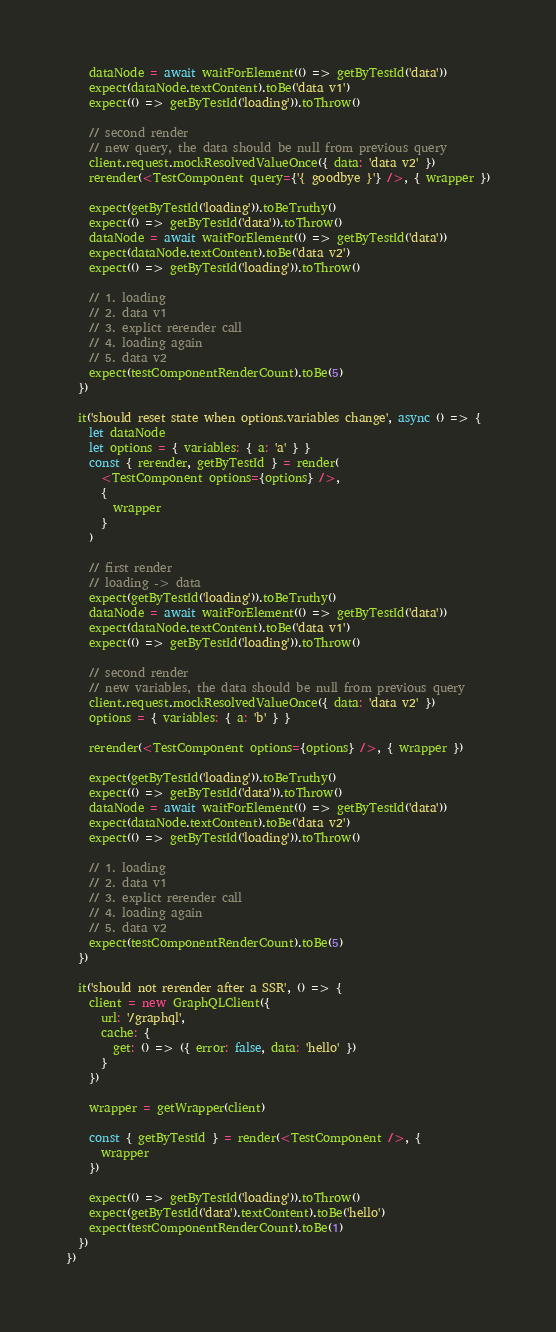Convert code to text. <code><loc_0><loc_0><loc_500><loc_500><_JavaScript_>    dataNode = await waitForElement(() => getByTestId('data'))
    expect(dataNode.textContent).toBe('data v1')
    expect(() => getByTestId('loading')).toThrow()

    // second render
    // new query, the data should be null from previous query
    client.request.mockResolvedValueOnce({ data: 'data v2' })
    rerender(<TestComponent query={'{ goodbye }'} />, { wrapper })

    expect(getByTestId('loading')).toBeTruthy()
    expect(() => getByTestId('data')).toThrow()
    dataNode = await waitForElement(() => getByTestId('data'))
    expect(dataNode.textContent).toBe('data v2')
    expect(() => getByTestId('loading')).toThrow()

    // 1. loading
    // 2. data v1
    // 3. explict rerender call
    // 4. loading again
    // 5. data v2
    expect(testComponentRenderCount).toBe(5)
  })

  it('should reset state when options.variables change', async () => {
    let dataNode
    let options = { variables: { a: 'a' } }
    const { rerender, getByTestId } = render(
      <TestComponent options={options} />,
      {
        wrapper
      }
    )

    // first render
    // loading -> data
    expect(getByTestId('loading')).toBeTruthy()
    dataNode = await waitForElement(() => getByTestId('data'))
    expect(dataNode.textContent).toBe('data v1')
    expect(() => getByTestId('loading')).toThrow()

    // second render
    // new variables, the data should be null from previous query
    client.request.mockResolvedValueOnce({ data: 'data v2' })
    options = { variables: { a: 'b' } }

    rerender(<TestComponent options={options} />, { wrapper })

    expect(getByTestId('loading')).toBeTruthy()
    expect(() => getByTestId('data')).toThrow()
    dataNode = await waitForElement(() => getByTestId('data'))
    expect(dataNode.textContent).toBe('data v2')
    expect(() => getByTestId('loading')).toThrow()

    // 1. loading
    // 2. data v1
    // 3. explict rerender call
    // 4. loading again
    // 5. data v2
    expect(testComponentRenderCount).toBe(5)
  })

  it('should not rerender after a SSR', () => {
    client = new GraphQLClient({
      url: '/graphql',
      cache: {
        get: () => ({ error: false, data: 'hello' })
      }
    })

    wrapper = getWrapper(client)

    const { getByTestId } = render(<TestComponent />, {
      wrapper
    })

    expect(() => getByTestId('loading')).toThrow()
    expect(getByTestId('data').textContent).toBe('hello')
    expect(testComponentRenderCount).toBe(1)
  })
})
</code> 